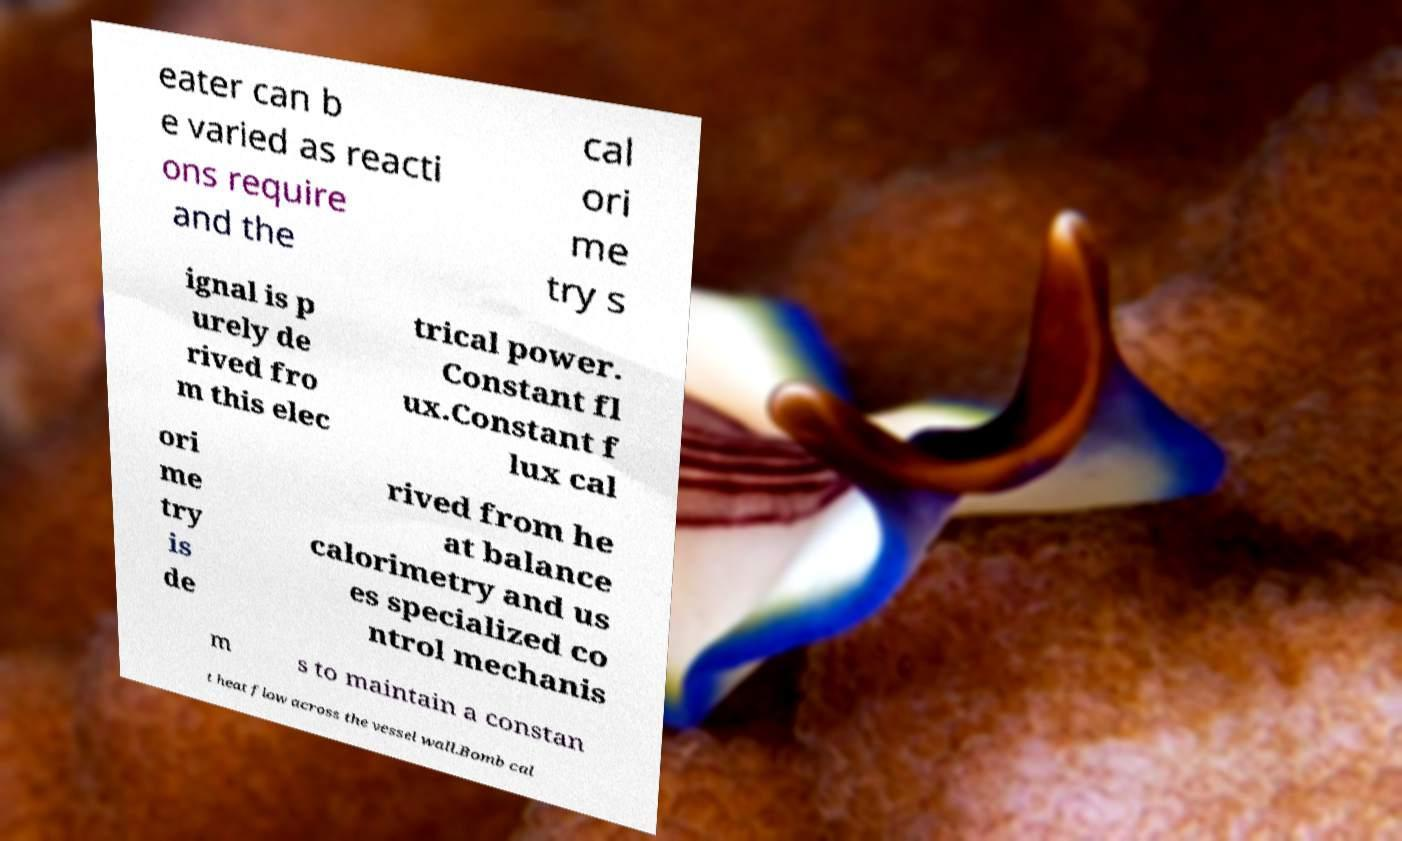What messages or text are displayed in this image? I need them in a readable, typed format. eater can b e varied as reacti ons require and the cal ori me try s ignal is p urely de rived fro m this elec trical power. Constant fl ux.Constant f lux cal ori me try is de rived from he at balance calorimetry and us es specialized co ntrol mechanis m s to maintain a constan t heat flow across the vessel wall.Bomb cal 